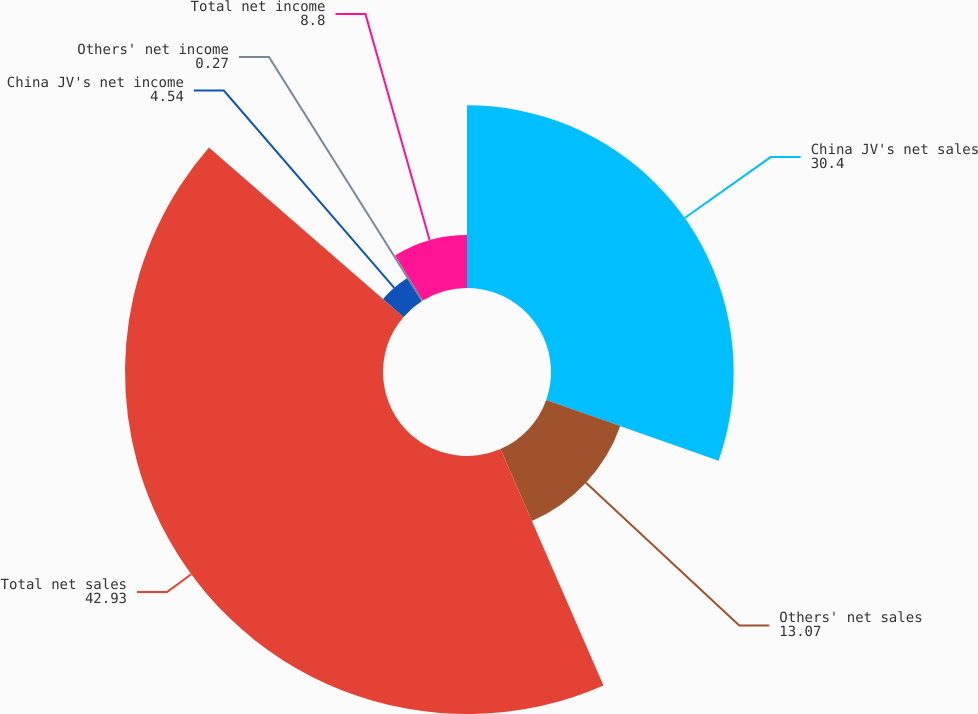Convert chart. <chart><loc_0><loc_0><loc_500><loc_500><pie_chart><fcel>China JV's net sales<fcel>Others' net sales<fcel>Total net sales<fcel>China JV's net income<fcel>Others' net income<fcel>Total net income<nl><fcel>30.4%<fcel>13.07%<fcel>42.93%<fcel>4.54%<fcel>0.27%<fcel>8.8%<nl></chart> 